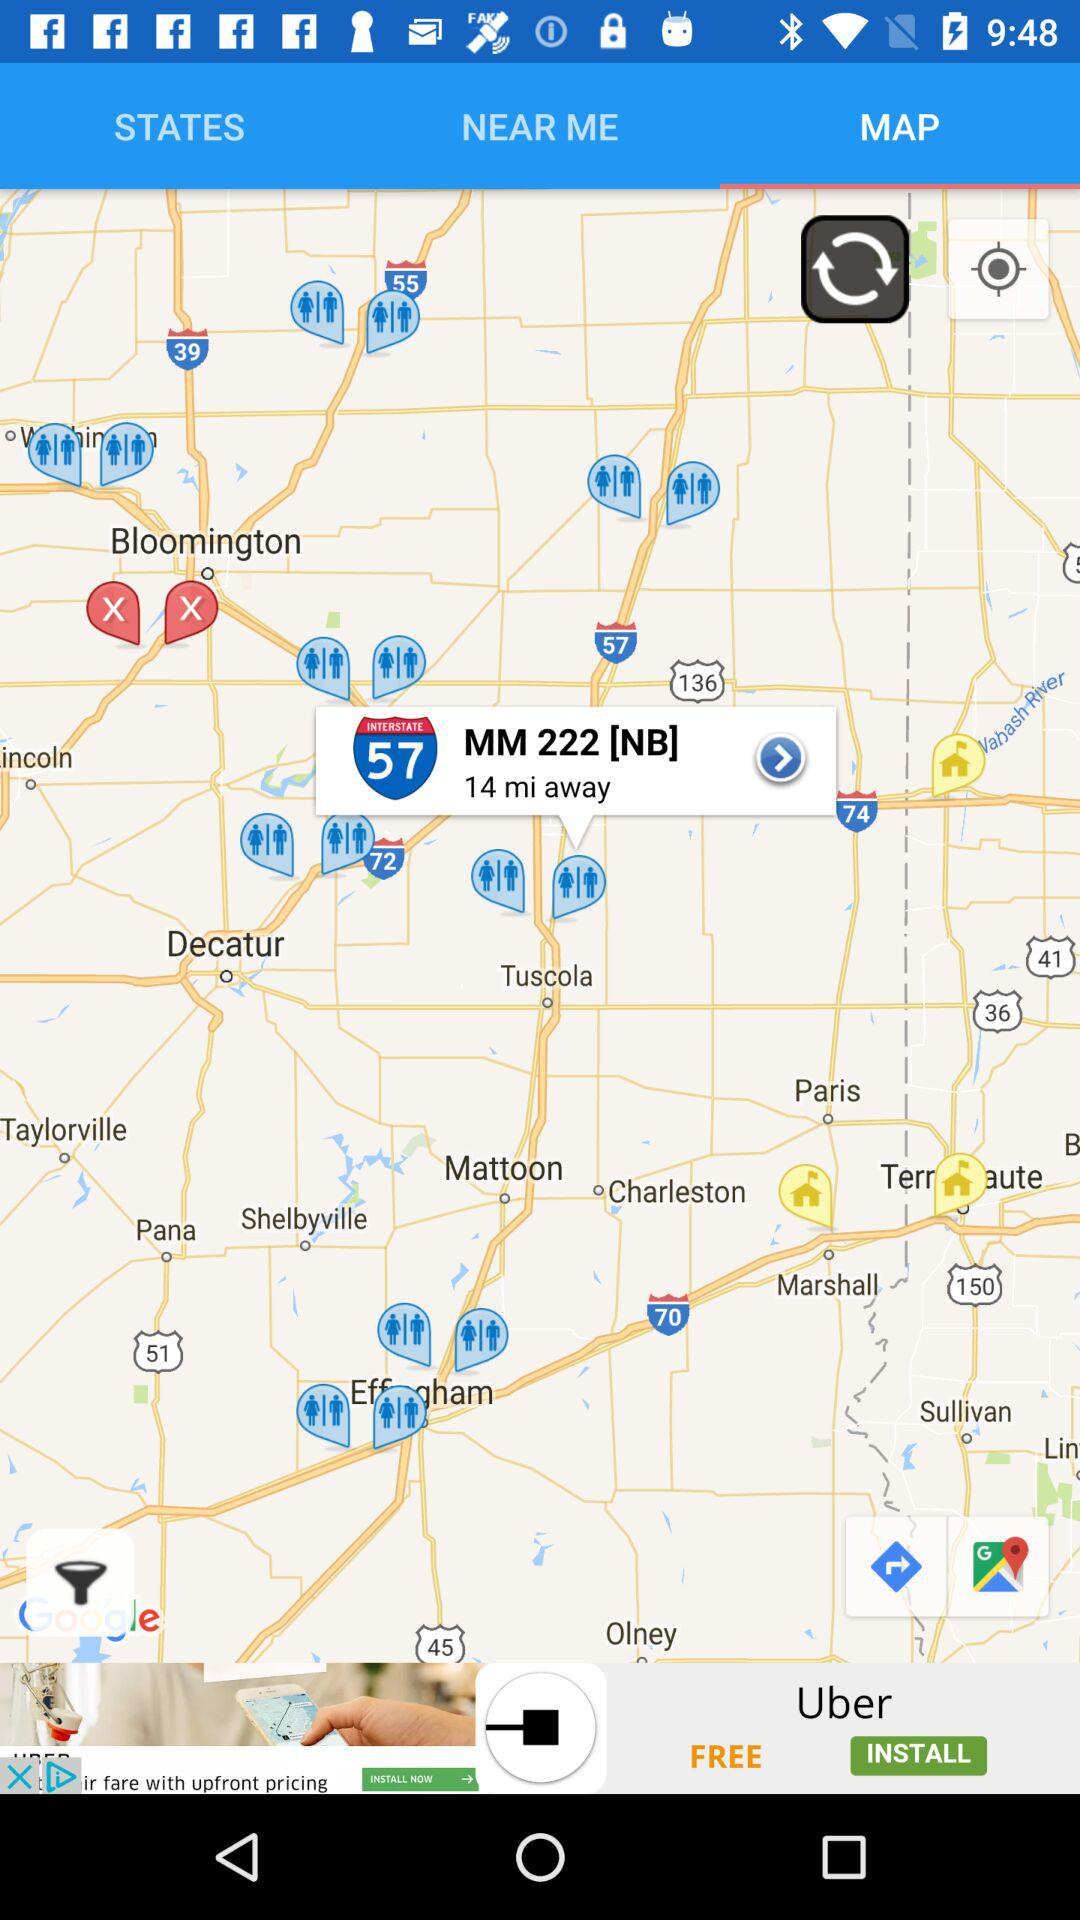Which tab is selected? The selected tab is "MAP". 